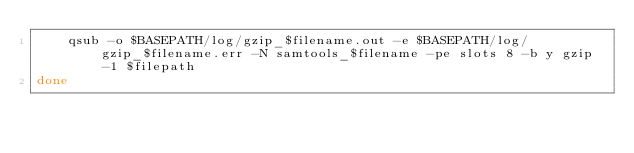Convert code to text. <code><loc_0><loc_0><loc_500><loc_500><_Bash_>	qsub -o $BASEPATH/log/gzip_$filename.out -e $BASEPATH/log/gzip_$filename.err -N samtools_$filename -pe slots 8 -b y gzip -1 $filepath
done
</code> 